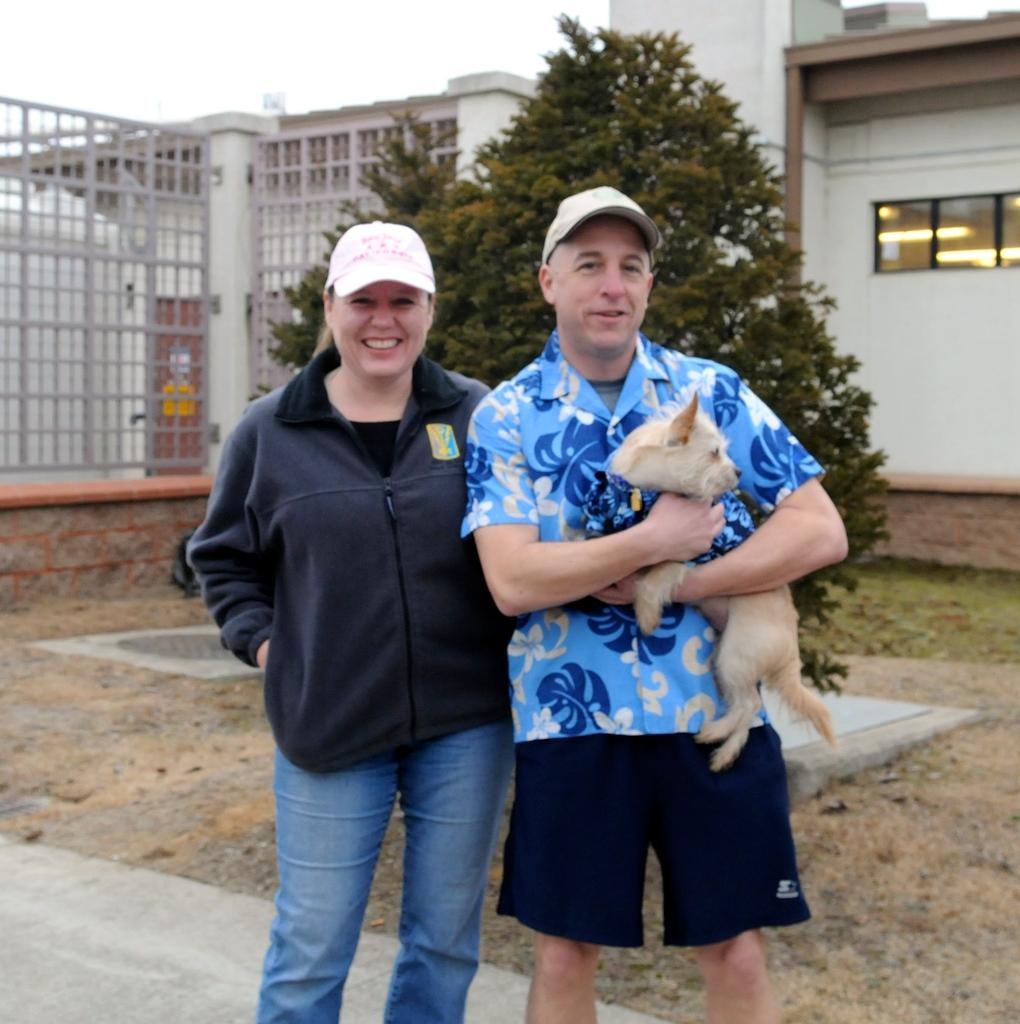Who are the people in the image? There is a man and a woman in the image. What is the man holding in the image? The man is holding a dog in the image. What can be seen in the background of the image? There is a tree and buildings in the background of the image. What type of box is the man using to pickle the dog in the image? There is no box or pickling activity present in the image; the man is simply holding a dog. 